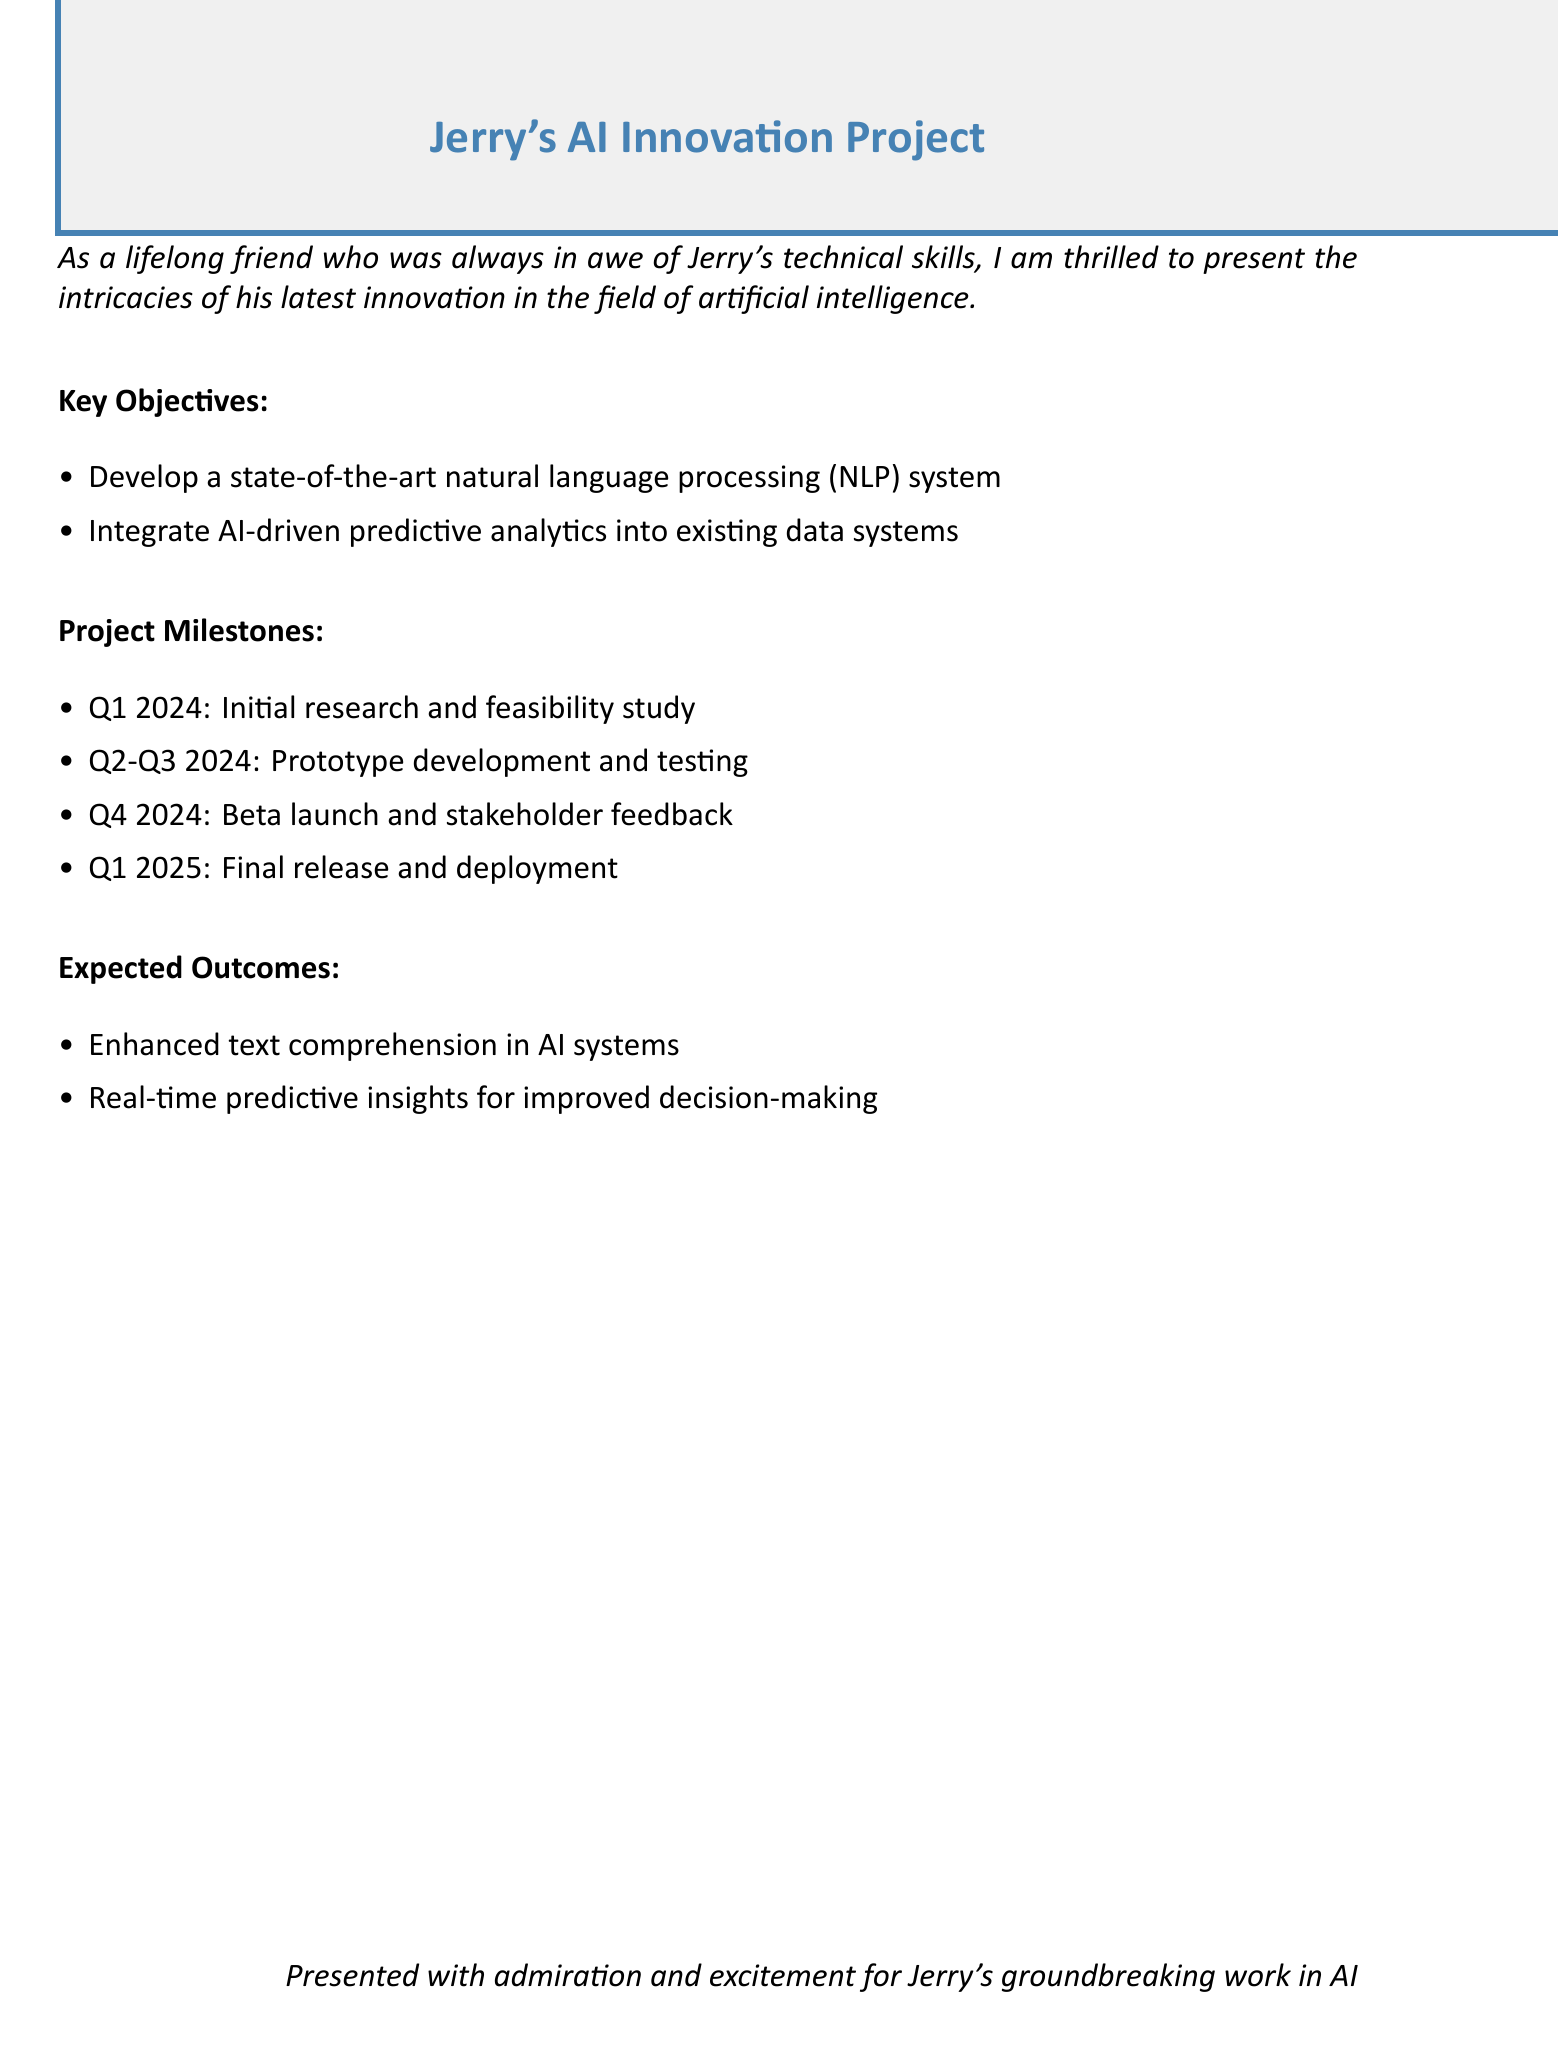What is the title of the project? The title of the project is stated at the top of the document.
Answer: Jerry's AI Innovation Project What is the main objective of the project? The main objective is specified in the list of key objectives.
Answer: Develop a state-of-the-art natural language processing system When is the final release scheduled? The timeline for the final release is mentioned under project milestones.
Answer: Q1 2025 What phase follows the beta launch? The sequence of project milestones indicates what comes after beta launch.
Answer: Final release and deployment What is one expected outcome of the project? The expected outcomes are summarized in the document.
Answer: Enhanced text comprehension in AI systems How many project milestones are listed? The number of milestones is counted from the project milestones section.
Answer: Four What quarter begins the research phase? The starting point of the research phase is indicated in the milestones.
Answer: Q1 2024 Which Q's are dedicated to prototype development? The specific quarters assigned to prototype development are noted in the milestones.
Answer: Q2-Q3 2024 